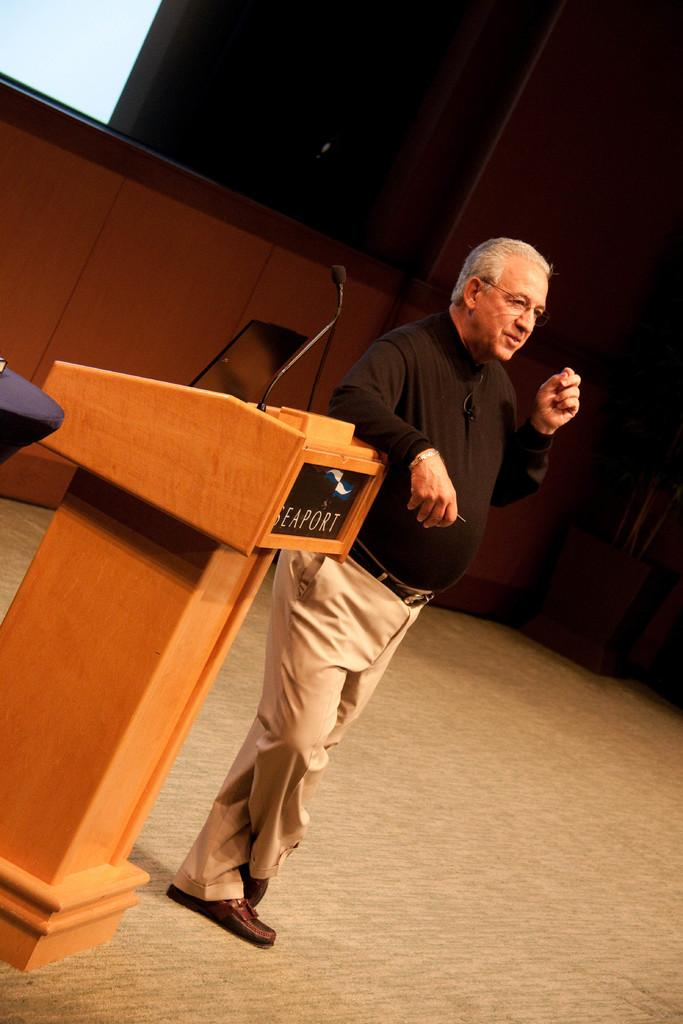What is the man in the image doing? The man is standing beside a laptop in the image. What object is on the podium in the image? There is a microphone on a podium in the image. What can be seen in the background of the image? There is a wall and a plant with a pot in the background of the image. What type of nest can be seen in the image? There is no nest present in the image; it features a man standing beside a laptop, a microphone on a podium, a wall, and a plant with a pot in the background. 